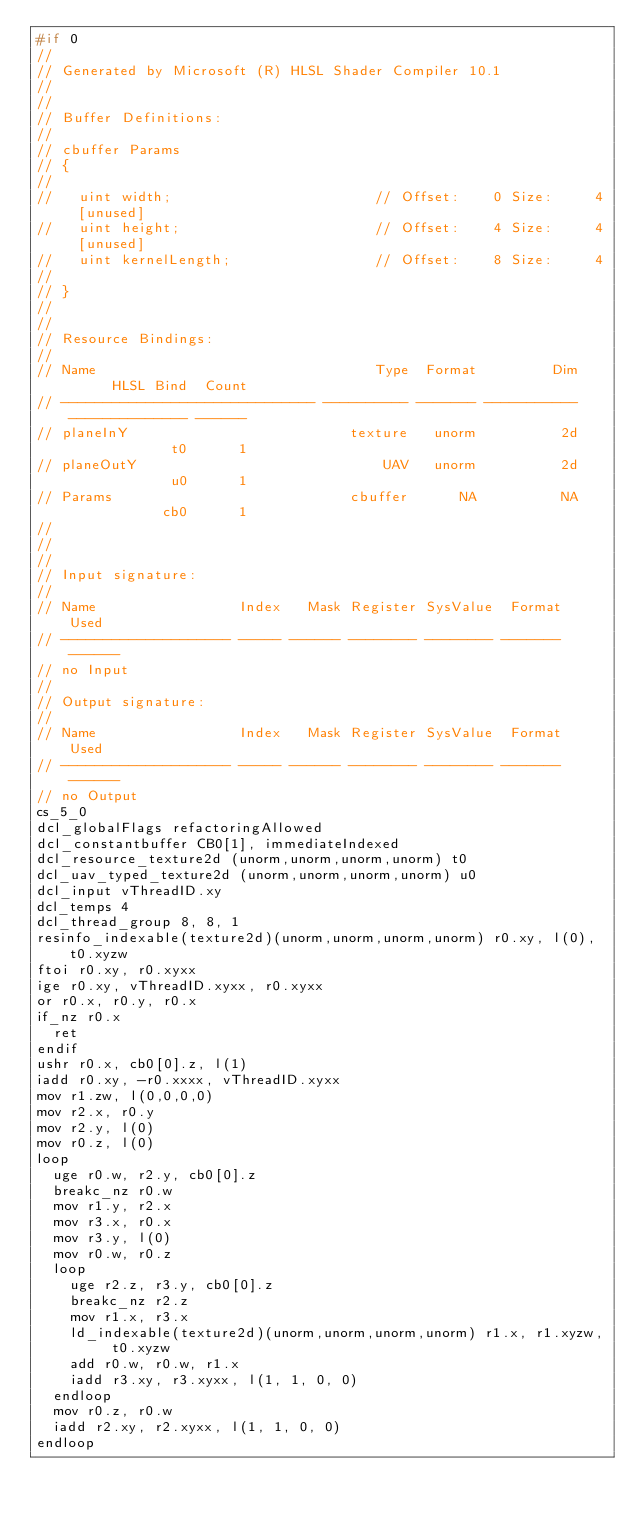<code> <loc_0><loc_0><loc_500><loc_500><_C_>#if 0
//
// Generated by Microsoft (R) HLSL Shader Compiler 10.1
//
//
// Buffer Definitions: 
//
// cbuffer Params
// {
//
//   uint width;                        // Offset:    0 Size:     4 [unused]
//   uint height;                       // Offset:    4 Size:     4 [unused]
//   uint kernelLength;                 // Offset:    8 Size:     4
//
// }
//
//
// Resource Bindings:
//
// Name                                 Type  Format         Dim      HLSL Bind  Count
// ------------------------------ ---------- ------- ----------- -------------- ------
// planeInY                          texture   unorm          2d             t0      1 
// planeOutY                             UAV   unorm          2d             u0      1 
// Params                            cbuffer      NA          NA            cb0      1 
//
//
//
// Input signature:
//
// Name                 Index   Mask Register SysValue  Format   Used
// -------------------- ----- ------ -------- -------- ------- ------
// no Input
//
// Output signature:
//
// Name                 Index   Mask Register SysValue  Format   Used
// -------------------- ----- ------ -------- -------- ------- ------
// no Output
cs_5_0
dcl_globalFlags refactoringAllowed
dcl_constantbuffer CB0[1], immediateIndexed
dcl_resource_texture2d (unorm,unorm,unorm,unorm) t0
dcl_uav_typed_texture2d (unorm,unorm,unorm,unorm) u0
dcl_input vThreadID.xy
dcl_temps 4
dcl_thread_group 8, 8, 1
resinfo_indexable(texture2d)(unorm,unorm,unorm,unorm) r0.xy, l(0), t0.xyzw
ftoi r0.xy, r0.xyxx
ige r0.xy, vThreadID.xyxx, r0.xyxx
or r0.x, r0.y, r0.x
if_nz r0.x
  ret 
endif 
ushr r0.x, cb0[0].z, l(1)
iadd r0.xy, -r0.xxxx, vThreadID.xyxx
mov r1.zw, l(0,0,0,0)
mov r2.x, r0.y
mov r2.y, l(0)
mov r0.z, l(0)
loop 
  uge r0.w, r2.y, cb0[0].z
  breakc_nz r0.w
  mov r1.y, r2.x
  mov r3.x, r0.x
  mov r3.y, l(0)
  mov r0.w, r0.z
  loop 
    uge r2.z, r3.y, cb0[0].z
    breakc_nz r2.z
    mov r1.x, r3.x
    ld_indexable(texture2d)(unorm,unorm,unorm,unorm) r1.x, r1.xyzw, t0.xyzw
    add r0.w, r0.w, r1.x
    iadd r3.xy, r3.xyxx, l(1, 1, 0, 0)
  endloop 
  mov r0.z, r0.w
  iadd r2.xy, r2.xyxx, l(1, 1, 0, 0)
endloop </code> 